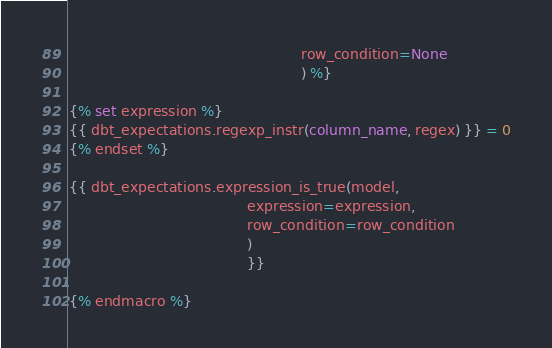Convert code to text. <code><loc_0><loc_0><loc_500><loc_500><_SQL_>                                                    row_condition=None
                                                    ) %}

{% set expression %}
{{ dbt_expectations.regexp_instr(column_name, regex) }} = 0
{% endset %}

{{ dbt_expectations.expression_is_true(model,
                                        expression=expression,
                                        row_condition=row_condition
                                        )
                                        }}

{% endmacro %}
</code> 